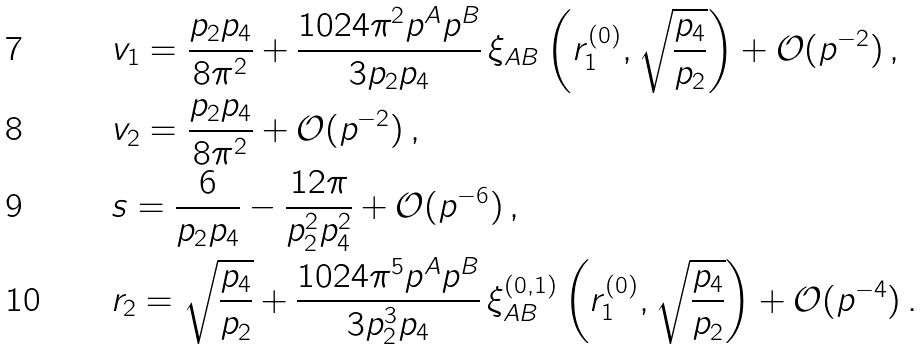Convert formula to latex. <formula><loc_0><loc_0><loc_500><loc_500>& v _ { 1 } = \frac { p _ { 2 } p _ { 4 } } { 8 \pi ^ { 2 } } + \frac { 1 0 2 4 \pi ^ { 2 } p ^ { A } p ^ { B } } { 3 p _ { 2 } p _ { 4 } } \, \xi _ { A B } \left ( r _ { 1 } ^ { ( 0 ) } , \sqrt { \frac { p _ { 4 } } { p _ { 2 } } } \right ) + \mathcal { O } ( p ^ { - 2 } ) \, , \\ & v _ { 2 } = \frac { p _ { 2 } p _ { 4 } } { 8 \pi ^ { 2 } } + \mathcal { O } ( p ^ { - 2 } ) \, , \\ & s = \frac { 6 } { p _ { 2 } p _ { 4 } } - \frac { 1 2 \pi } { p _ { 2 } ^ { 2 } p _ { 4 } ^ { 2 } } + \mathcal { O } ( p ^ { - 6 } ) \, , \\ & r _ { 2 } = \sqrt { \frac { p _ { 4 } } { p _ { 2 } } } + \frac { 1 0 2 4 \pi ^ { 5 } p ^ { A } p ^ { B } } { 3 p _ { 2 } ^ { 3 } p _ { 4 } } \, \xi _ { A B } ^ { ( 0 , 1 ) } \left ( r _ { 1 } ^ { ( 0 ) } , \sqrt { \frac { p _ { 4 } } { p _ { 2 } } } \right ) + \mathcal { O } ( p ^ { - 4 } ) \, .</formula> 